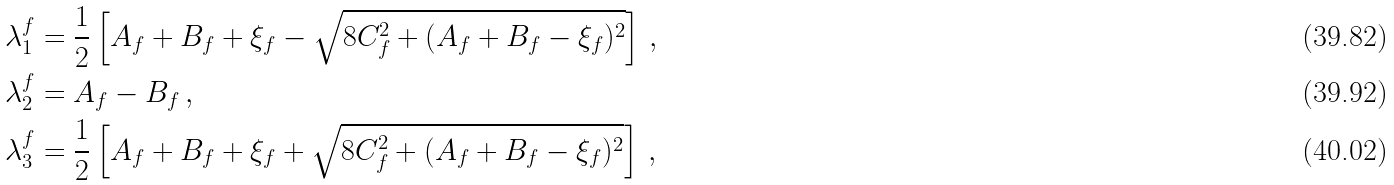<formula> <loc_0><loc_0><loc_500><loc_500>\lambda _ { 1 } ^ { f } & = \frac { 1 } { 2 } \left [ A _ { f } + B _ { f } + \xi _ { f } - \sqrt { 8 C _ { f } ^ { 2 } + ( A _ { f } + B _ { f } - \xi _ { f } ) ^ { 2 } } \right ] \, , \\ \lambda _ { 2 } ^ { f } & = A _ { f } - B _ { f } \, , \\ \lambda _ { 3 } ^ { f } & = \frac { 1 } { 2 } \left [ A _ { f } + B _ { f } + \xi _ { f } + \sqrt { 8 C _ { f } ^ { 2 } + ( A _ { f } + B _ { f } - \xi _ { f } ) ^ { 2 } } \right ] \, ,</formula> 